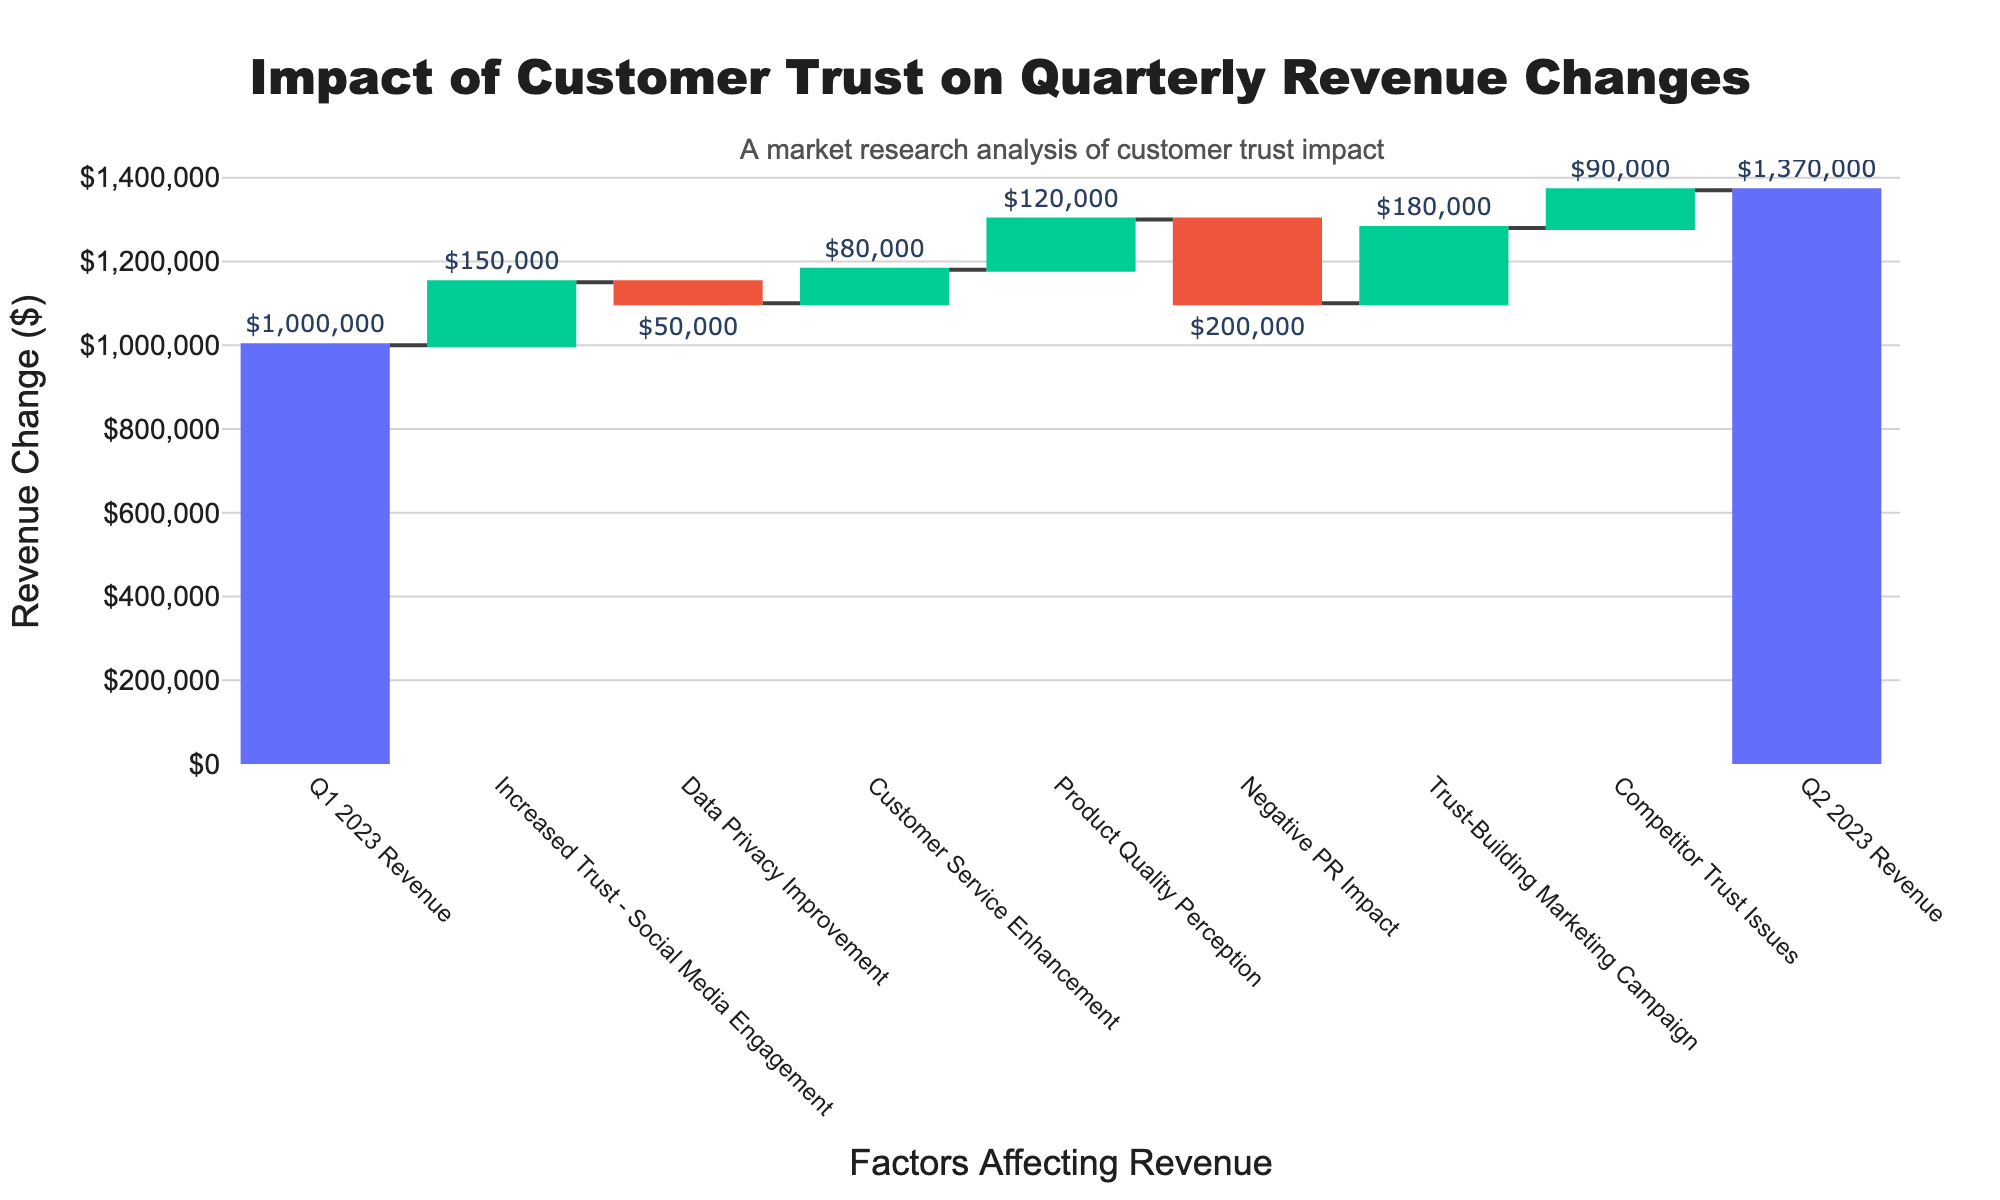What's the title of the waterfall chart? The title of the chart is displayed at the top of the figure. It reads "Impact of Customer Trust on Quarterly Revenue Changes".
Answer: Impact of Customer Trust on Quarterly Revenue Changes How much revenue impact did the "Increased Trust - Social Media Engagement" have? The weight of "Increased Trust - Social Media Engagement" on revenue is indicated by the bar and its label. It shows an increase in revenue by $150,000.
Answer: $150,000 What was the total impact of negative factors on the revenue? There are two negative factors: "Data Privacy Improvement" with -$50,000 and "Negative PR Impact" with -$200,000. Summing these gives the total negative impact: -$50,000 + -$200,000 = -$250,000.
Answer: -$250,000 Which factor had the highest positive impact on revenue? To find the highest impact, look at all the positive bars. The highest bar represents "Trust-Building Marketing Campaign" which increased revenue by $180,000.
Answer: Trust-Building Marketing Campaign By how much did the "Customer Service Enhancement" improve the revenue? The bar for "Customer Service Enhancement" shows an increase, and its label indicates a revenue increase of $80,000.
Answer: $80,000 What is the net change in revenue from Q1 2023 to Q2 2023? The net change is shown by the difference between the starting figure for Q1 2023 (1,000,000) and the ending figure for Q2 2023 (1,370,000). Calculating it: 1,370,000 - 1,000,000 = $370,000.
Answer: $370,000 Which factor had a relatively modest positive impact compared to others? Comparing all positive impact bars visually, "Competitor Trust Issues" increased the revenue by $90,000, which is modest relative to others like "Product Quality Perception" or "Trust-Building Marketing Campaign".
Answer: Competitor Trust Issues How did the "Data Privacy Improvement" affect the revenue, and what color indicates its impact? The "Data Privacy Improvement" caused a decrease of $50,000 in revenue. This is indicated by a red-colored bar, representing a negative impact.
Answer: It decreased revenue by $50,000, colored red What are the start and end revenue values as per the chart? The initial revenue (Q1 2023) is $1,000,000 and the final revenue (Q2 2023) is $1,370,000 as indicated by the starting and ending values on the chart.
Answer: $1,000,000 and $1,370,000 Which factors cumulatively resulted in a revenue increase of more than $300,000? Examine the factors contributing positively: "Increased Trust - Social Media Engagement" ($150,000), "Customer Service Enhancement" ($80,000), "Product Quality Perception" ($120,000), "Trust-Building Marketing Campaign" ($180,000), and "Competitor Trust Issues" ($90,000). Summing these: 150,000 + 80,000 + 120,000 + 180,000 + 90,000 = $620,000.
Answer: Several factors with a net increase of $620,000 